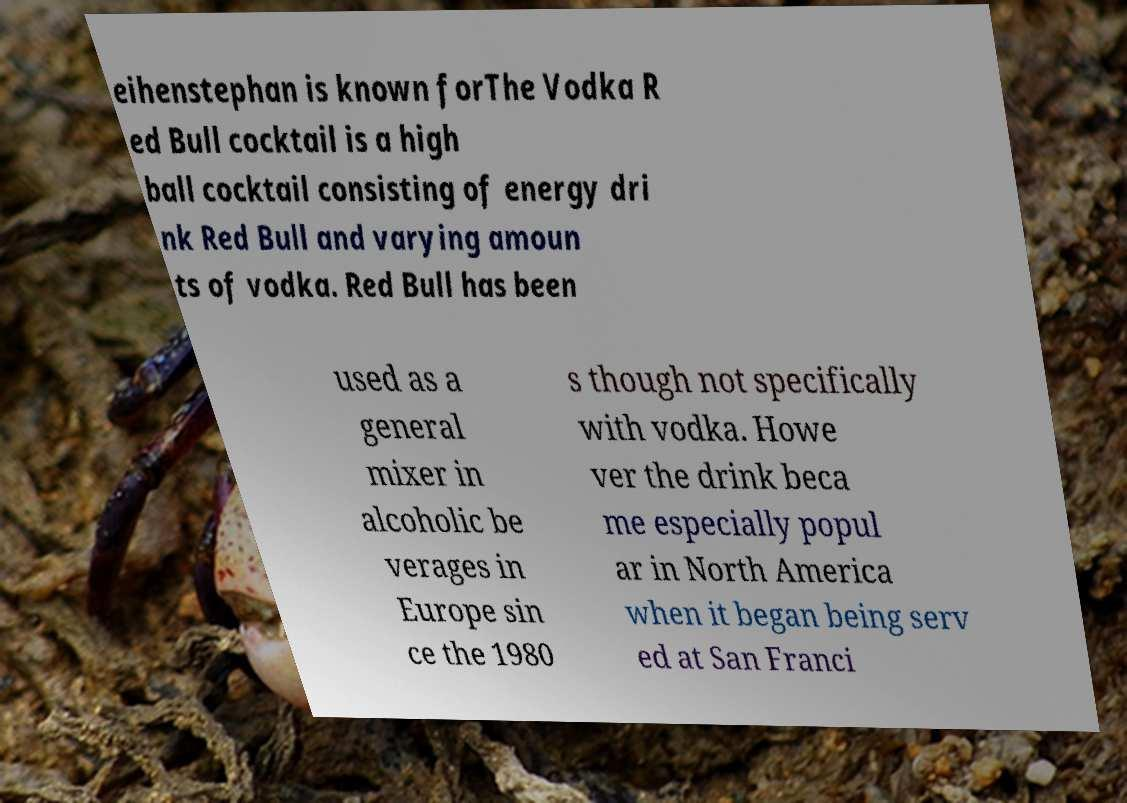There's text embedded in this image that I need extracted. Can you transcribe it verbatim? eihenstephan is known forThe Vodka R ed Bull cocktail is a high ball cocktail consisting of energy dri nk Red Bull and varying amoun ts of vodka. Red Bull has been used as a general mixer in alcoholic be verages in Europe sin ce the 1980 s though not specifically with vodka. Howe ver the drink beca me especially popul ar in North America when it began being serv ed at San Franci 